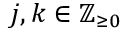<formula> <loc_0><loc_0><loc_500><loc_500>j , k \in \mathbb { Z } _ { \geq 0 }</formula> 